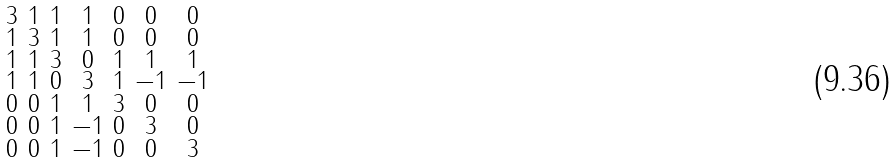Convert formula to latex. <formula><loc_0><loc_0><loc_500><loc_500>\begin{smallmatrix} 3 & 1 & 1 & 1 & 0 & 0 & 0 \\ 1 & 3 & 1 & 1 & 0 & 0 & 0 \\ 1 & 1 & 3 & 0 & 1 & 1 & 1 \\ 1 & 1 & 0 & 3 & 1 & - 1 & - 1 \\ 0 & 0 & 1 & 1 & 3 & 0 & 0 \\ 0 & 0 & 1 & - 1 & 0 & 3 & 0 \\ 0 & 0 & 1 & - 1 & 0 & 0 & 3 \end{smallmatrix}</formula> 